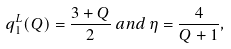Convert formula to latex. <formula><loc_0><loc_0><loc_500><loc_500>q ^ { L } _ { 1 } ( Q ) = \frac { 3 + Q } { 2 } \, a n d \, \eta = \frac { 4 } { Q + 1 } ,</formula> 